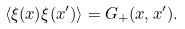<formula> <loc_0><loc_0><loc_500><loc_500>\langle \xi ( x ) \xi ( x ^ { \prime } ) \rangle = G _ { + } ( x , x ^ { \prime } ) .</formula> 